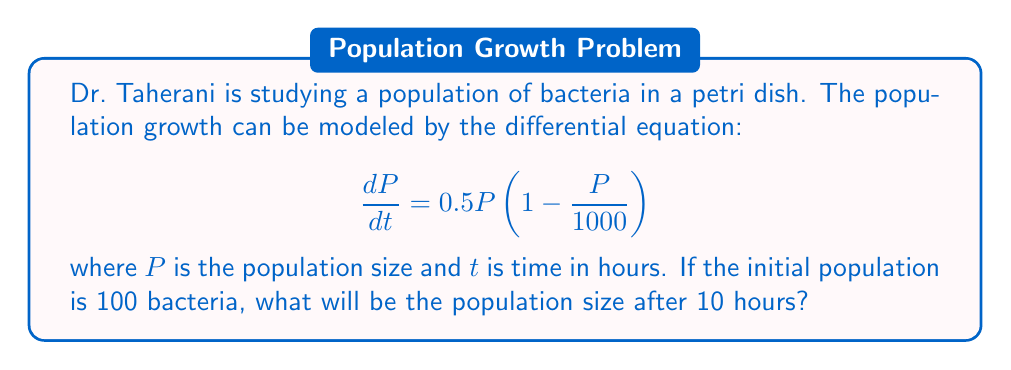Can you solve this math problem? To solve this differential equation, we need to follow these steps:

1) First, we recognize this as a logistic growth model with a carrying capacity of 1000 and a growth rate of 0.5.

2) The general solution for a logistic growth model is:

   $$P(t) = \frac{K}{1 + \left(\frac{K}{P_0} - 1\right)e^{-rt}}$$

   where $K$ is the carrying capacity, $P_0$ is the initial population, and $r$ is the growth rate.

3) Substituting our values:
   $K = 1000$, $P_0 = 100$, $r = 0.5$, and $t = 10$

4) Now we can plug these into our equation:

   $$P(10) = \frac{1000}{1 + \left(\frac{1000}{100} - 1\right)e^{-0.5(10)}}$$

5) Simplify:
   $$P(10) = \frac{1000}{1 + 9e^{-5}}$$

6) Calculate $e^{-5} \approx 0.00674$

7) Substitute this value:
   $$P(10) = \frac{1000}{1 + 9(0.00674)} \approx \frac{1000}{1.06066}$$

8) Evaluate:
   $$P(10) \approx 942.85$$

9) Since we're dealing with a population of bacteria, we round to the nearest whole number.
Answer: 943 bacteria 